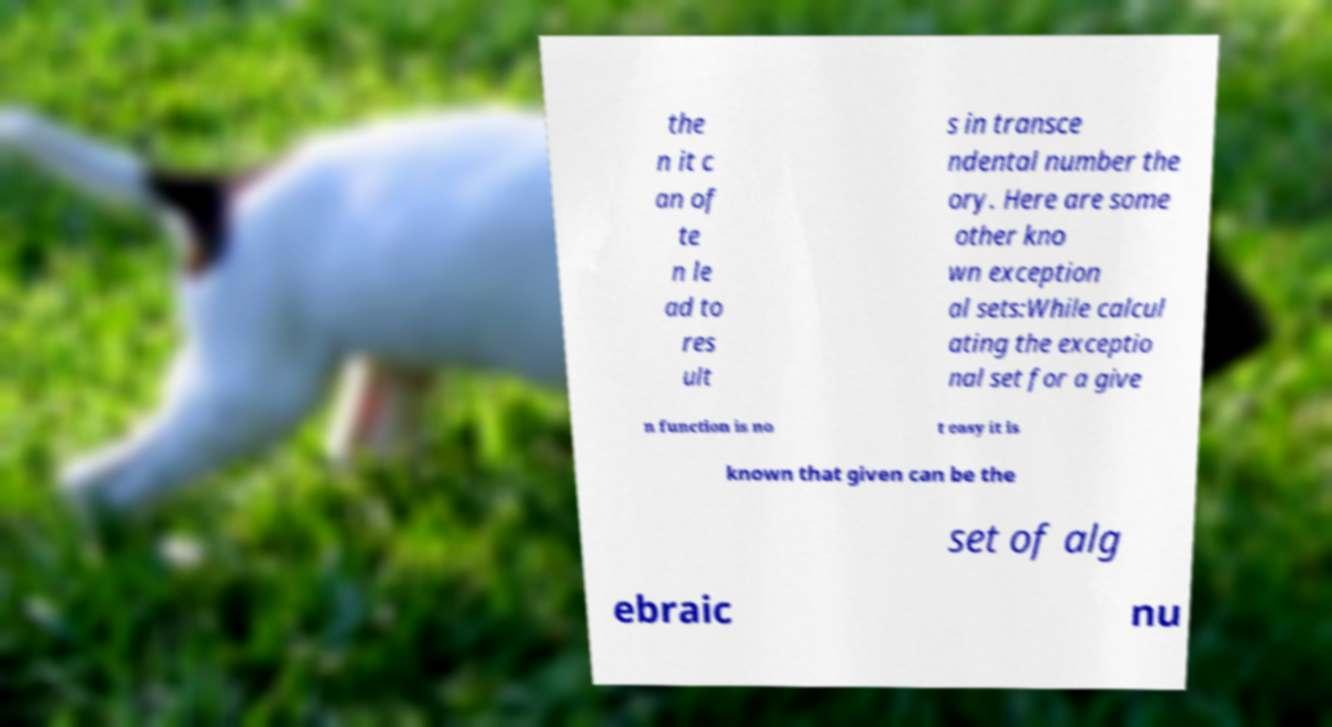Please identify and transcribe the text found in this image. the n it c an of te n le ad to res ult s in transce ndental number the ory. Here are some other kno wn exception al sets:While calcul ating the exceptio nal set for a give n function is no t easy it is known that given can be the set of alg ebraic nu 